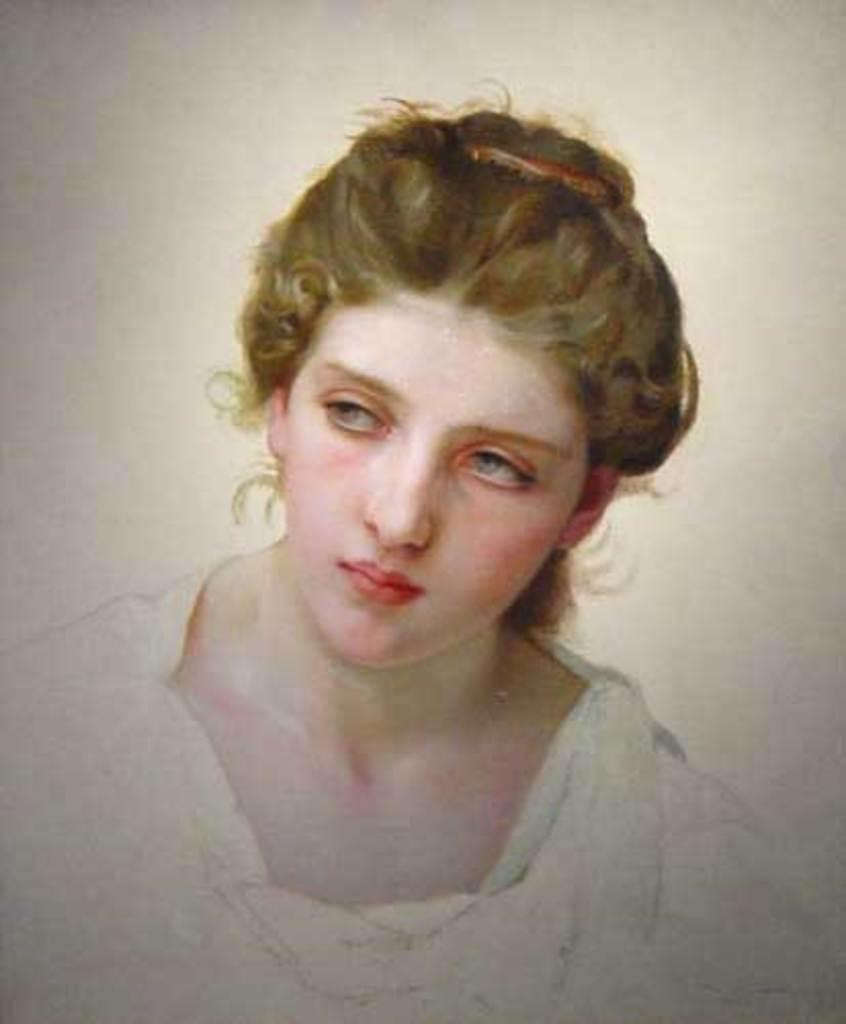What type of artwork is shown in the image? The image is a painting. What subject is depicted in the painting? There is a woman depicted in the painting. How many eggs can be seen in the painting? There are no eggs present in the painting; it depicts a woman. What type of footwear is the woman wearing in the painting? The painting does not show the woman's footwear, as only her upper body is visible. 